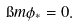Convert formula to latex. <formula><loc_0><loc_0><loc_500><loc_500>\i m \phi _ { * } = 0 .</formula> 